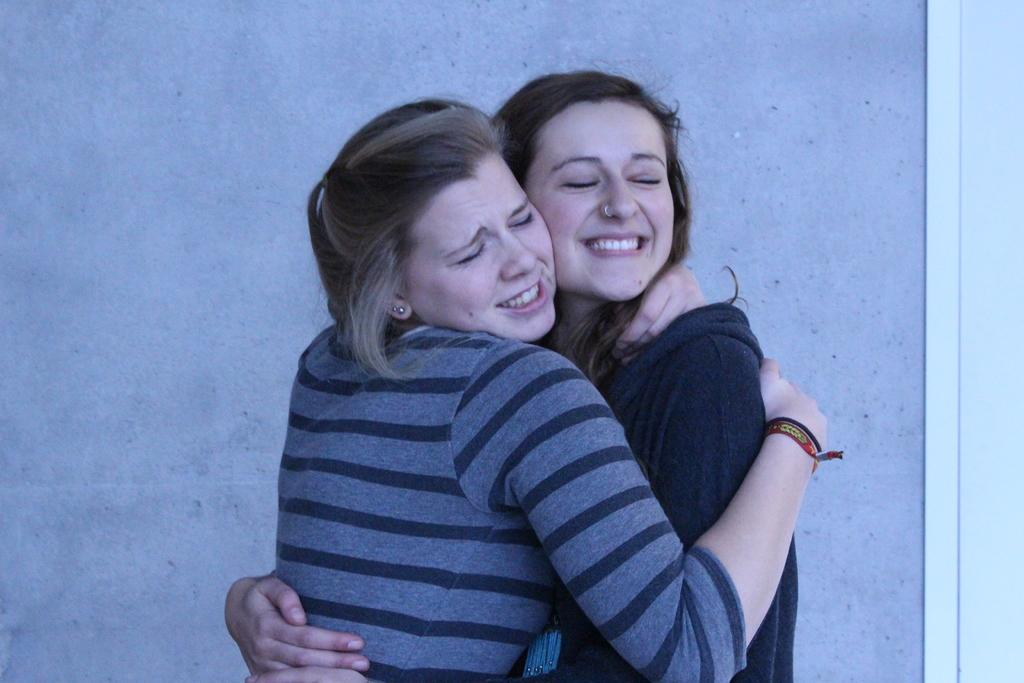How many people are in the image? There are two ladies in the center of the image. What can be seen in the background of the image? There is a wall in the background of the image. What type of harmony is being played by the ladies in the image? There is no indication of music or harmony in the image; it only shows two ladies in the center. 